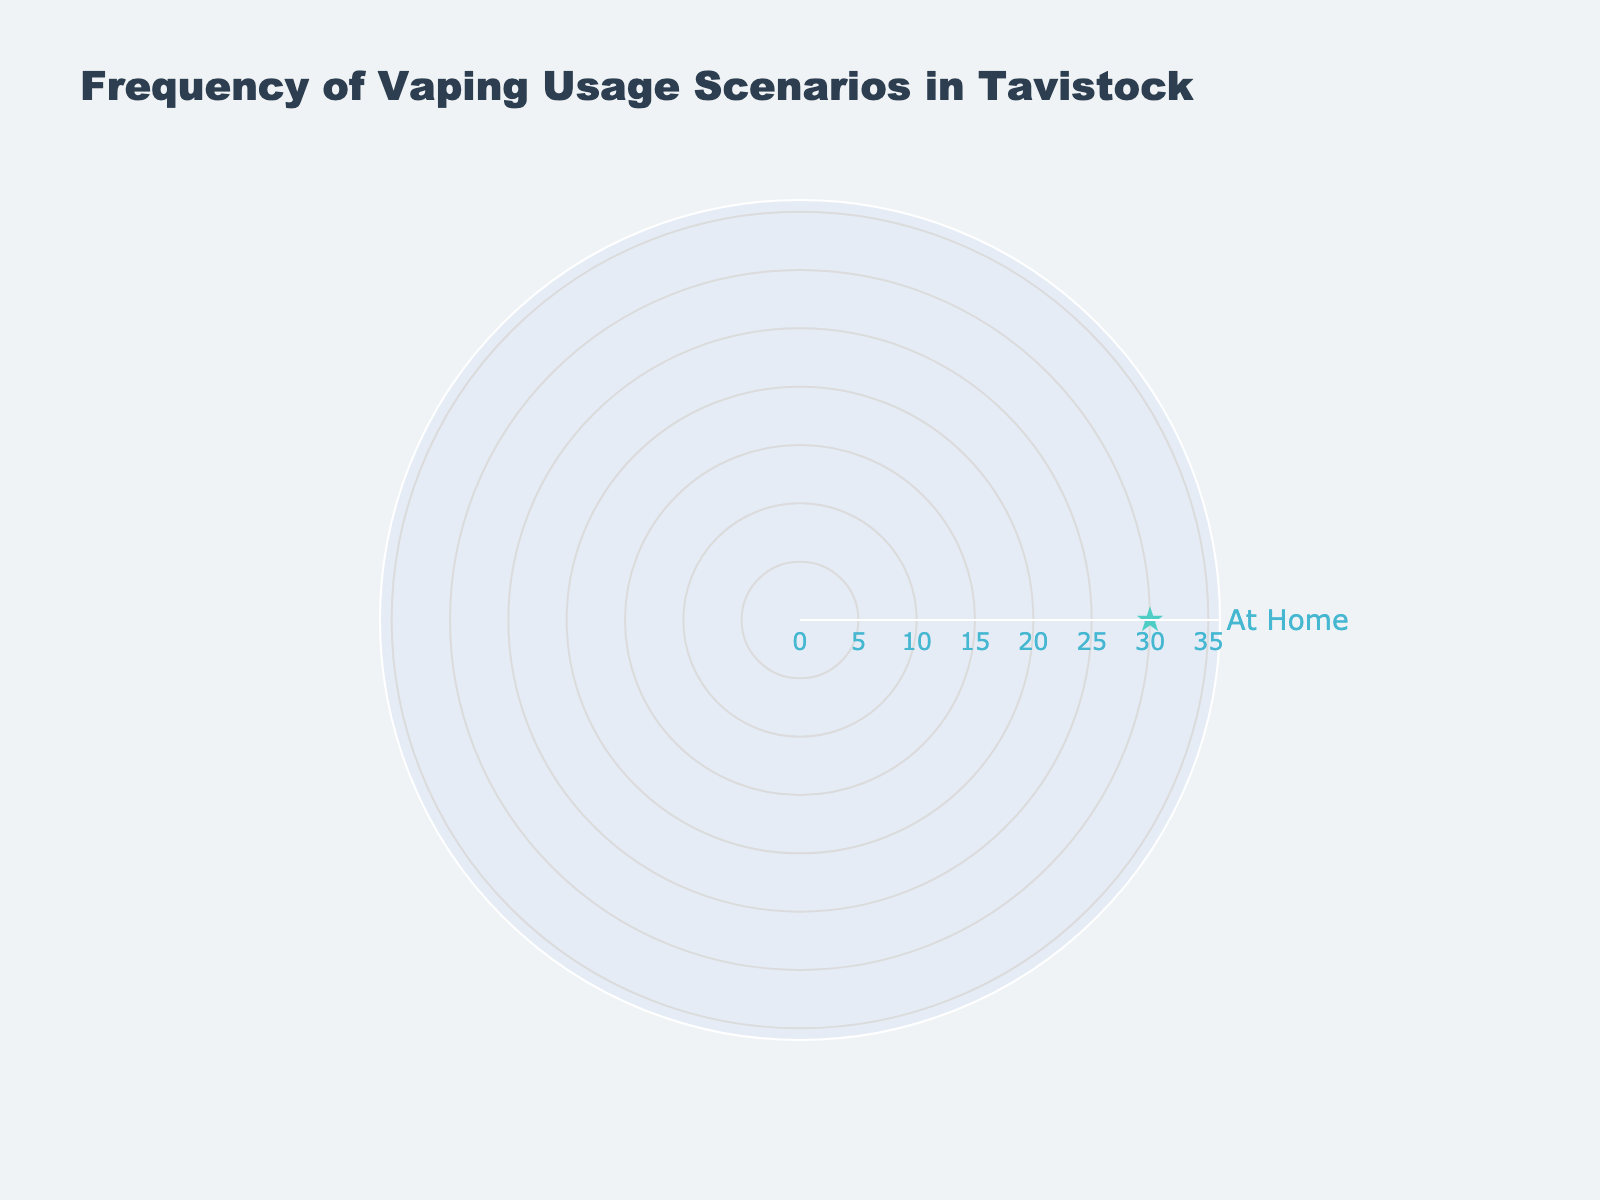what is the title of the radar chart? The title of the radar chart is located at the top of the figure and reads "Frequency of Vaping Usage Scenarios in Tavistock".
Answer: Frequency of Vaping Usage Scenarios in Tavistock How many usage scenarios are displayed in the radar chart? There is only one usage scenario shown, which can be counted from the single category listed on the outer edge of the radar chart.
Answer: 1 What is the percentage for the "At Home" usage scenario? The value next to the "At Home" label on the radar chart shows the percentage of vaping usage in this scenario as 30%.
Answer: 30% Could the maximum value be greater than 30%? Since 30% is the only given value, and there’s only one scenario, the maximum value of the chart range is automatically set to slightly higher than 30% to accommodate this value.
Answer: No What is the color of the line connecting the data points in the radar chart? The color of the line connecting the data points is described as "#FF6B6B" in the chart’s configuration, which appears as a shade of red.
Answer: Red What color are the data markers in the radar chart? The markers in the radar chart are colored "#4ECDC4", which appears as a shade of teal.
Answer: Teal Can you compare multiple usage scenarios using this radar chart? No, because there is only one usage scenario provided ("At Home"), it is not possible to make comparisons with other scenarios as there are no other data points shown.
Answer: No 